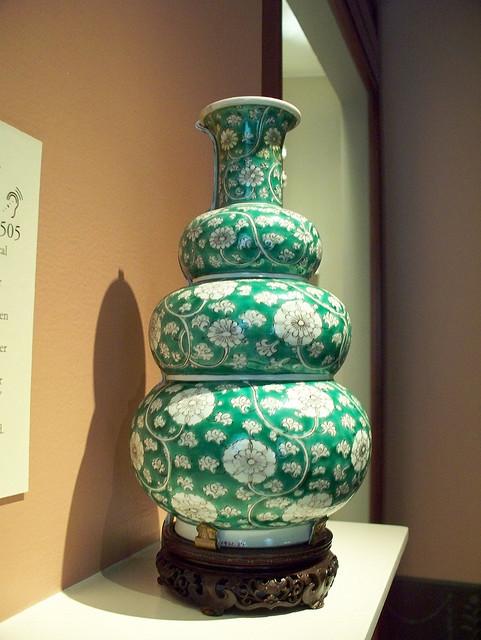What is the painting depicting?
Give a very brief answer. Flowers. Could this be a museum?
Be succinct. Yes. What color is the stripe on the vase?
Short answer required. White. Is there a flower pattern on the vase?
Give a very brief answer. Yes. How many vases are in the picture?
Short answer required. 1. What color is the wall?
Write a very short answer. Tan. Is this a palm tree growing in a vase?
Be succinct. No. What type of pottery is this?
Short answer required. Vase. What kind of wall is this?
Quick response, please. Drywall. What color is the table?
Give a very brief answer. White. What color is the vase?
Short answer required. Green. Is there anything coming out of the green vase?
Concise answer only. No. 